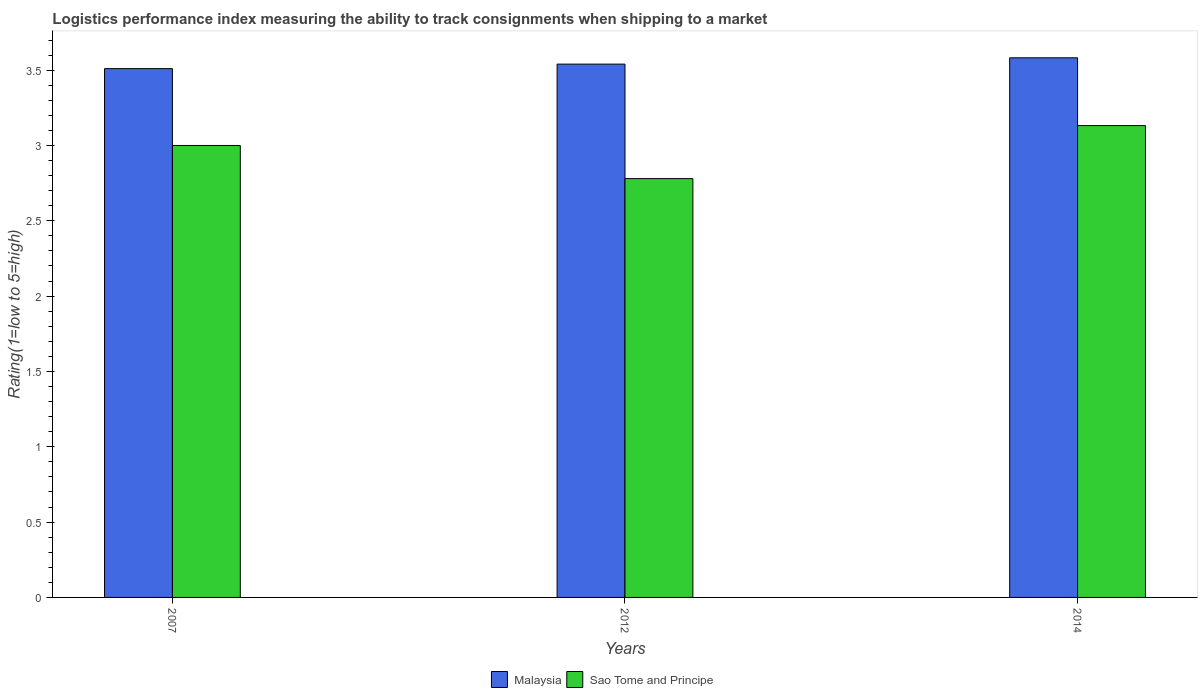How many different coloured bars are there?
Offer a very short reply. 2. Are the number of bars per tick equal to the number of legend labels?
Keep it short and to the point. Yes. Are the number of bars on each tick of the X-axis equal?
Offer a terse response. Yes. How many bars are there on the 2nd tick from the right?
Provide a succinct answer. 2. What is the label of the 2nd group of bars from the left?
Provide a succinct answer. 2012. What is the Logistic performance index in Sao Tome and Principe in 2012?
Make the answer very short. 2.78. Across all years, what is the maximum Logistic performance index in Malaysia?
Provide a short and direct response. 3.58. Across all years, what is the minimum Logistic performance index in Sao Tome and Principe?
Offer a terse response. 2.78. In which year was the Logistic performance index in Malaysia minimum?
Offer a terse response. 2007. What is the total Logistic performance index in Malaysia in the graph?
Your response must be concise. 10.63. What is the difference between the Logistic performance index in Malaysia in 2012 and that in 2014?
Provide a succinct answer. -0.04. What is the difference between the Logistic performance index in Malaysia in 2014 and the Logistic performance index in Sao Tome and Principe in 2012?
Ensure brevity in your answer.  0.8. What is the average Logistic performance index in Malaysia per year?
Give a very brief answer. 3.54. In the year 2014, what is the difference between the Logistic performance index in Malaysia and Logistic performance index in Sao Tome and Principe?
Offer a terse response. 0.45. What is the ratio of the Logistic performance index in Malaysia in 2007 to that in 2012?
Your response must be concise. 0.99. What is the difference between the highest and the second highest Logistic performance index in Malaysia?
Offer a very short reply. 0.04. What is the difference between the highest and the lowest Logistic performance index in Malaysia?
Make the answer very short. 0.07. Is the sum of the Logistic performance index in Malaysia in 2012 and 2014 greater than the maximum Logistic performance index in Sao Tome and Principe across all years?
Provide a short and direct response. Yes. What does the 2nd bar from the left in 2007 represents?
Provide a succinct answer. Sao Tome and Principe. What does the 1st bar from the right in 2014 represents?
Offer a very short reply. Sao Tome and Principe. How many years are there in the graph?
Ensure brevity in your answer.  3. Are the values on the major ticks of Y-axis written in scientific E-notation?
Keep it short and to the point. No. Does the graph contain any zero values?
Give a very brief answer. No. Does the graph contain grids?
Make the answer very short. No. Where does the legend appear in the graph?
Offer a very short reply. Bottom center. How are the legend labels stacked?
Offer a very short reply. Horizontal. What is the title of the graph?
Keep it short and to the point. Logistics performance index measuring the ability to track consignments when shipping to a market. What is the label or title of the X-axis?
Ensure brevity in your answer.  Years. What is the label or title of the Y-axis?
Your answer should be compact. Rating(1=low to 5=high). What is the Rating(1=low to 5=high) in Malaysia in 2007?
Keep it short and to the point. 3.51. What is the Rating(1=low to 5=high) of Sao Tome and Principe in 2007?
Give a very brief answer. 3. What is the Rating(1=low to 5=high) of Malaysia in 2012?
Your answer should be compact. 3.54. What is the Rating(1=low to 5=high) of Sao Tome and Principe in 2012?
Provide a succinct answer. 2.78. What is the Rating(1=low to 5=high) of Malaysia in 2014?
Ensure brevity in your answer.  3.58. What is the Rating(1=low to 5=high) of Sao Tome and Principe in 2014?
Offer a very short reply. 3.13. Across all years, what is the maximum Rating(1=low to 5=high) in Malaysia?
Your answer should be compact. 3.58. Across all years, what is the maximum Rating(1=low to 5=high) of Sao Tome and Principe?
Your answer should be compact. 3.13. Across all years, what is the minimum Rating(1=low to 5=high) in Malaysia?
Ensure brevity in your answer.  3.51. Across all years, what is the minimum Rating(1=low to 5=high) of Sao Tome and Principe?
Offer a very short reply. 2.78. What is the total Rating(1=low to 5=high) in Malaysia in the graph?
Offer a very short reply. 10.63. What is the total Rating(1=low to 5=high) in Sao Tome and Principe in the graph?
Make the answer very short. 8.91. What is the difference between the Rating(1=low to 5=high) of Malaysia in 2007 and that in 2012?
Provide a short and direct response. -0.03. What is the difference between the Rating(1=low to 5=high) in Sao Tome and Principe in 2007 and that in 2012?
Make the answer very short. 0.22. What is the difference between the Rating(1=low to 5=high) in Malaysia in 2007 and that in 2014?
Offer a very short reply. -0.07. What is the difference between the Rating(1=low to 5=high) in Sao Tome and Principe in 2007 and that in 2014?
Offer a very short reply. -0.13. What is the difference between the Rating(1=low to 5=high) in Malaysia in 2012 and that in 2014?
Offer a terse response. -0.04. What is the difference between the Rating(1=low to 5=high) in Sao Tome and Principe in 2012 and that in 2014?
Keep it short and to the point. -0.35. What is the difference between the Rating(1=low to 5=high) in Malaysia in 2007 and the Rating(1=low to 5=high) in Sao Tome and Principe in 2012?
Your response must be concise. 0.73. What is the difference between the Rating(1=low to 5=high) of Malaysia in 2007 and the Rating(1=low to 5=high) of Sao Tome and Principe in 2014?
Your answer should be compact. 0.38. What is the difference between the Rating(1=low to 5=high) of Malaysia in 2012 and the Rating(1=low to 5=high) of Sao Tome and Principe in 2014?
Your answer should be very brief. 0.41. What is the average Rating(1=low to 5=high) of Malaysia per year?
Your response must be concise. 3.54. What is the average Rating(1=low to 5=high) in Sao Tome and Principe per year?
Provide a short and direct response. 2.97. In the year 2007, what is the difference between the Rating(1=low to 5=high) in Malaysia and Rating(1=low to 5=high) in Sao Tome and Principe?
Ensure brevity in your answer.  0.51. In the year 2012, what is the difference between the Rating(1=low to 5=high) in Malaysia and Rating(1=low to 5=high) in Sao Tome and Principe?
Your response must be concise. 0.76. In the year 2014, what is the difference between the Rating(1=low to 5=high) in Malaysia and Rating(1=low to 5=high) in Sao Tome and Principe?
Your answer should be compact. 0.45. What is the ratio of the Rating(1=low to 5=high) of Malaysia in 2007 to that in 2012?
Give a very brief answer. 0.99. What is the ratio of the Rating(1=low to 5=high) in Sao Tome and Principe in 2007 to that in 2012?
Your answer should be compact. 1.08. What is the ratio of the Rating(1=low to 5=high) in Malaysia in 2007 to that in 2014?
Your response must be concise. 0.98. What is the ratio of the Rating(1=low to 5=high) in Sao Tome and Principe in 2007 to that in 2014?
Make the answer very short. 0.96. What is the ratio of the Rating(1=low to 5=high) of Malaysia in 2012 to that in 2014?
Offer a terse response. 0.99. What is the ratio of the Rating(1=low to 5=high) of Sao Tome and Principe in 2012 to that in 2014?
Provide a short and direct response. 0.89. What is the difference between the highest and the second highest Rating(1=low to 5=high) in Malaysia?
Offer a very short reply. 0.04. What is the difference between the highest and the second highest Rating(1=low to 5=high) in Sao Tome and Principe?
Provide a succinct answer. 0.13. What is the difference between the highest and the lowest Rating(1=low to 5=high) in Malaysia?
Offer a very short reply. 0.07. What is the difference between the highest and the lowest Rating(1=low to 5=high) in Sao Tome and Principe?
Keep it short and to the point. 0.35. 